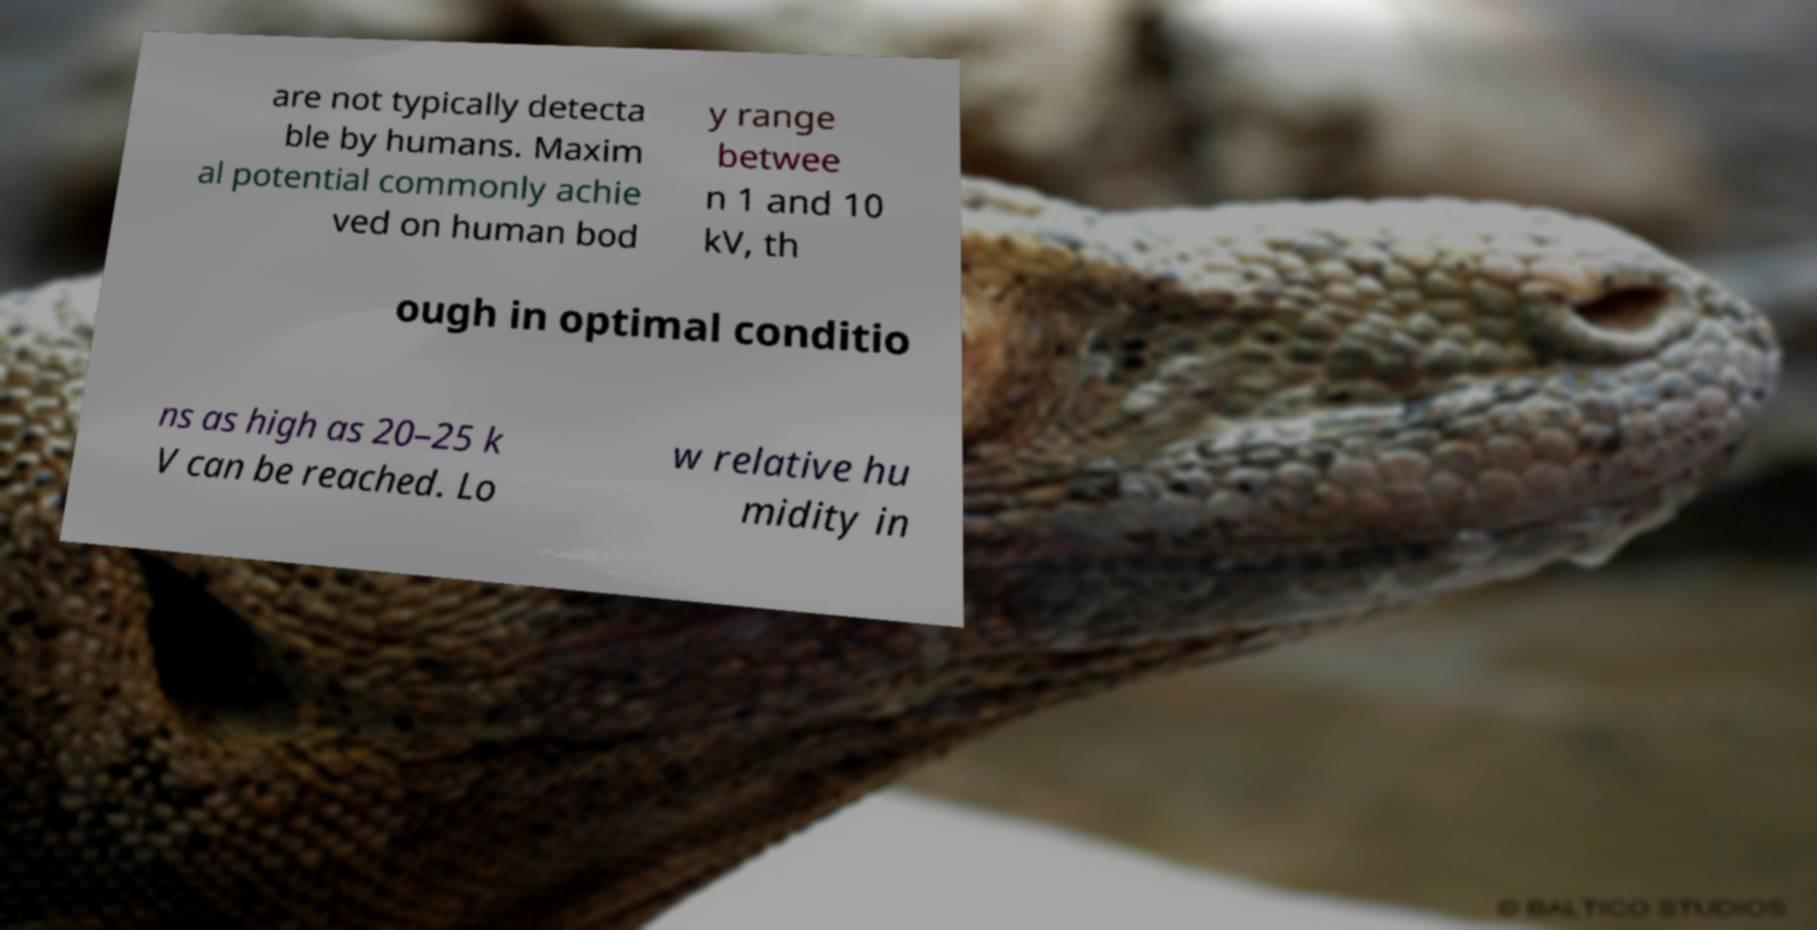I need the written content from this picture converted into text. Can you do that? are not typically detecta ble by humans. Maxim al potential commonly achie ved on human bod y range betwee n 1 and 10 kV, th ough in optimal conditio ns as high as 20–25 k V can be reached. Lo w relative hu midity in 